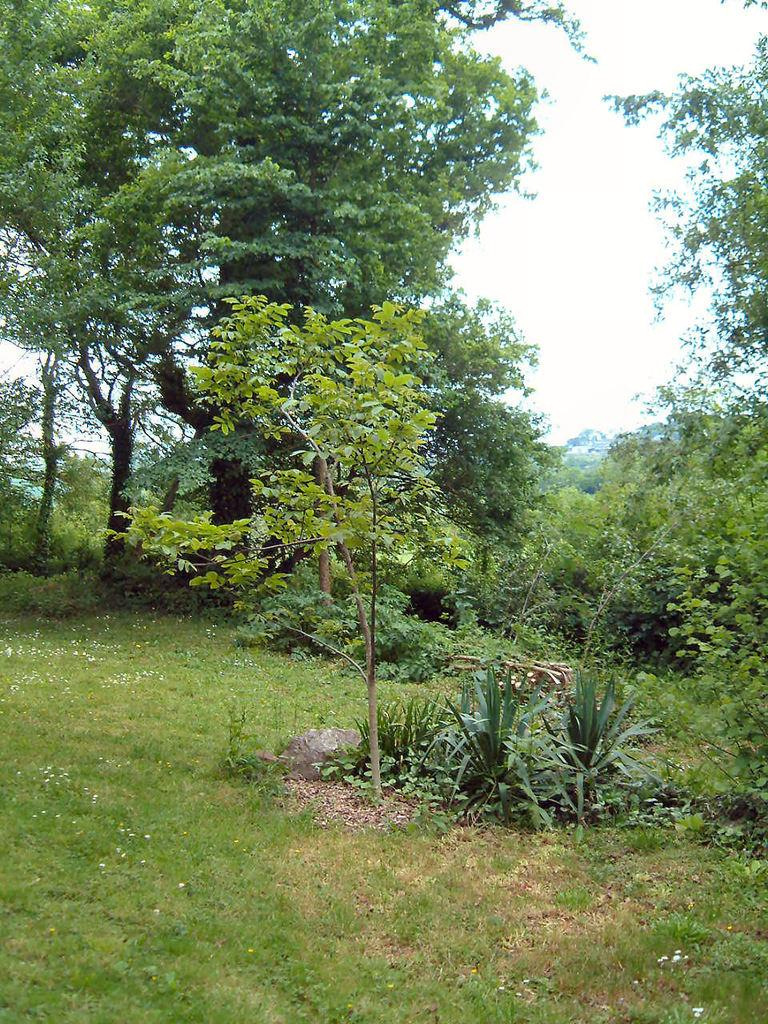What type of vegetation is present on the ground in the image? There are plants and grass on the ground in the image. What can be seen in the background of the image? There are trees in the background of the image. What is visible at the top of the image? The sky is visible at the top of the image. Are there any balloons visible in the image? No, there are no balloons present in the image. What type of weather is depicted in the image, considering it's winter? The provided facts do not mention any specific season or weather conditions, so it cannot be determined if it's winter or if any specific weather is depicted in the image. 